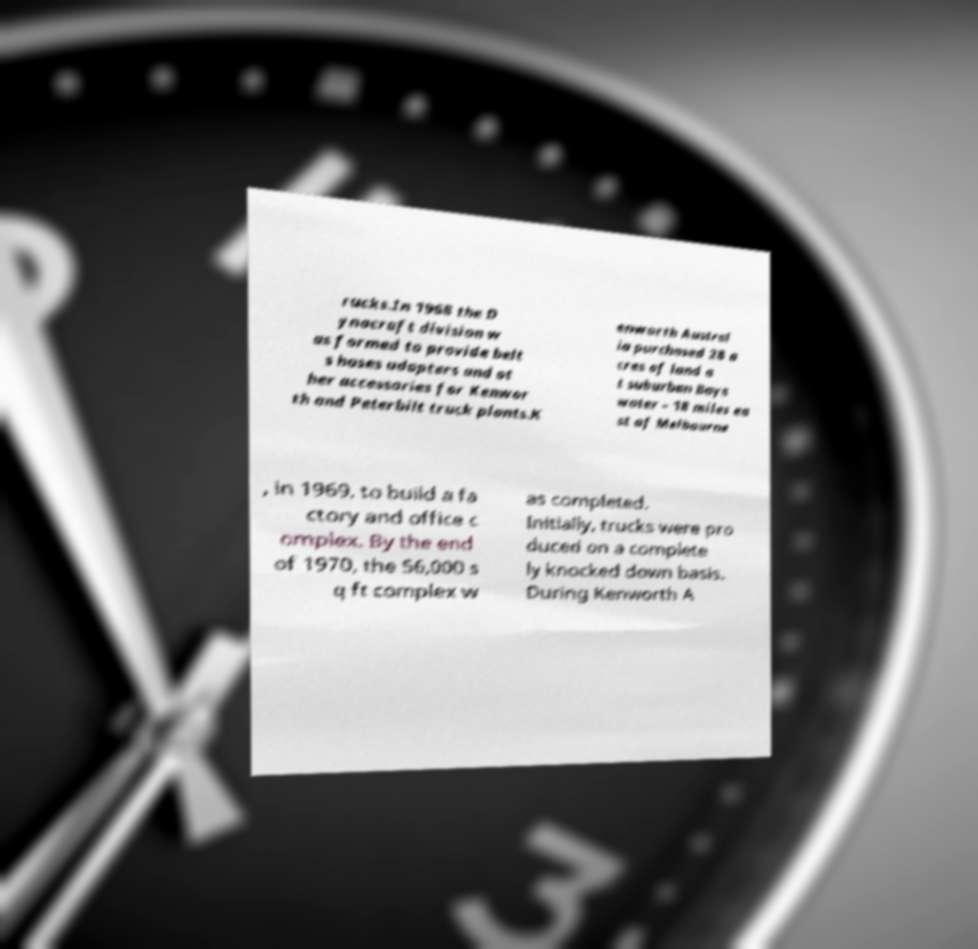Please identify and transcribe the text found in this image. rucks.In 1968 the D ynacraft division w as formed to provide belt s hoses adapters and ot her accessories for Kenwor th and Peterbilt truck plants.K enworth Austral ia purchased 28 a cres of land a t suburban Bays water – 18 miles ea st of Melbourne , in 1969, to build a fa ctory and office c omplex. By the end of 1970, the 56,000 s q ft complex w as completed. Initially, trucks were pro duced on a complete ly knocked down basis. During Kenworth A 